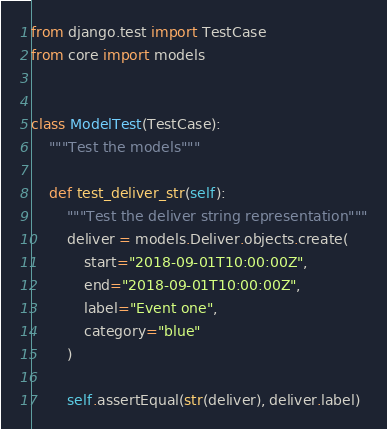<code> <loc_0><loc_0><loc_500><loc_500><_Python_>from django.test import TestCase
from core import models


class ModelTest(TestCase):
    """Test the models"""

    def test_deliver_str(self):
        """Test the deliver string representation"""
        deliver = models.Deliver.objects.create(
            start="2018-09-01T10:00:00Z",
            end="2018-09-01T10:00:00Z",
            label="Event one",
            category="blue"
        )

        self.assertEqual(str(deliver), deliver.label)
</code> 